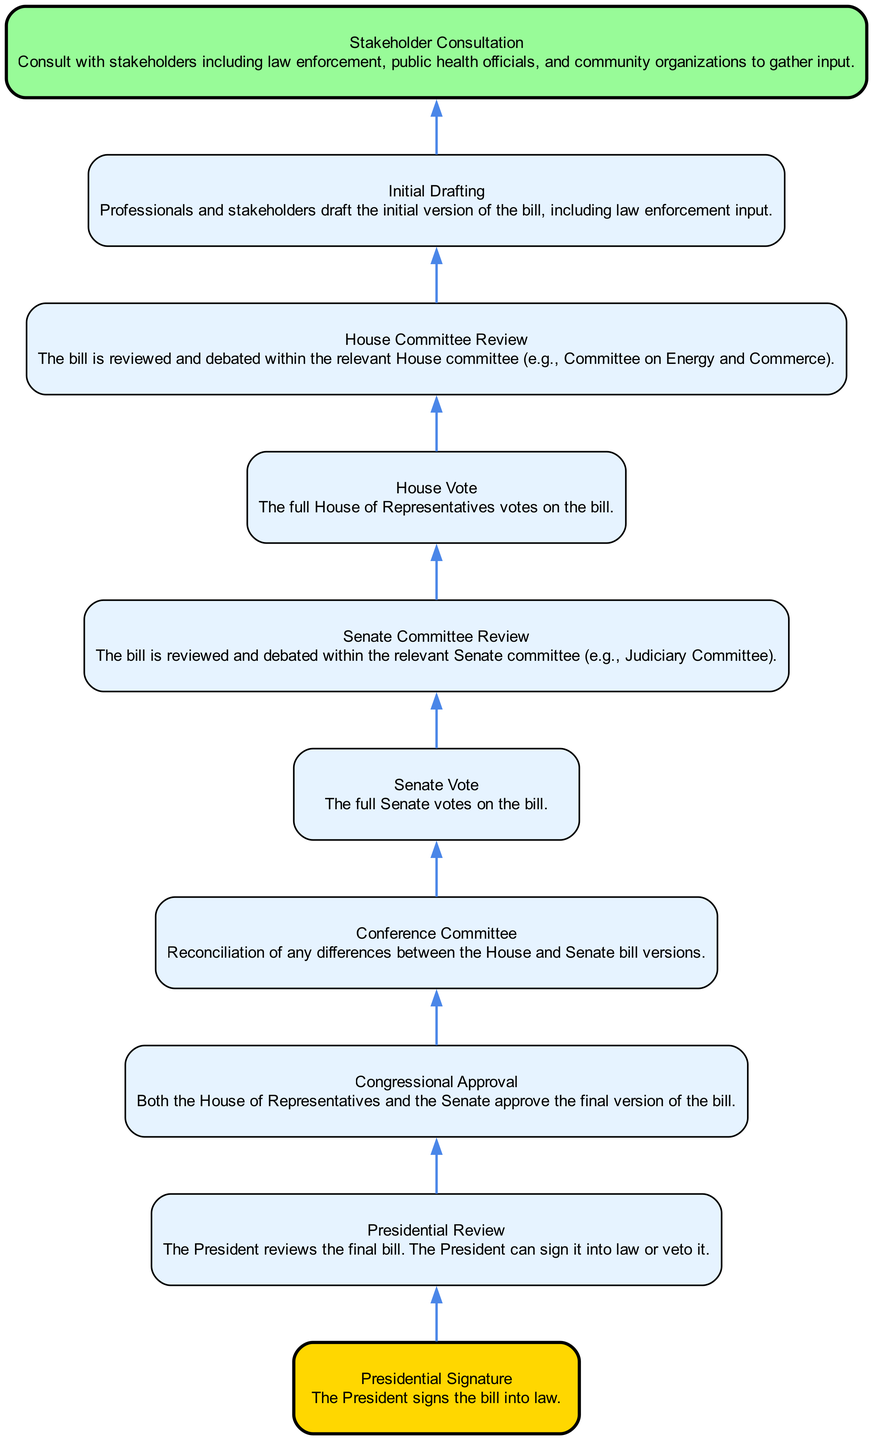What is the first step in the legislative process for enacting the substance abuse bill? The first step listed in the diagram is "Initial Drafting," where professionals and stakeholders draft the initial version of the bill, including law enforcement input.
Answer: Initial Drafting How many nodes are in the diagram? The diagram has a total of ten nodes representing each step in the legislative process.
Answer: 10 What follows after "Stakeholder Consultation"? After "Stakeholder Consultation," the next step is "Initial Drafting," indicating that the bill's initial version is created after consulting stakeholders.
Answer: Initial Drafting What happens during the "Conference Committee" stage? The "Conference Committee" stage involves reconciliation of any differences between the House and Senate bill versions, ensuring both chambers agree on the bill's content before the vote.
Answer: Reconciliation of differences Which step comes directly before "Presidential Signature"? "Presidential Review" comes directly before "Presidential Signature," as the President must review the bill before signing it into law or vetoing it.
Answer: Presidential Review What is the final outcome after "Presidential Signature"? The final outcome after "Presidential Signature" is that the bill is signed into law by the President, completing the legislative process.
Answer: Signed into law During which stage is the bill reviewed in the Senate? The bill is reviewed during the "Senate Committee Review" stage, where it is debated within the relevant Senate committee before it goes for a vote.
Answer: Senate Committee Review What must happen before "Congressional Approval"? Before "Congressional Approval," the full Senate must vote on the bill after it has been reviewed in the Senate committee, and the House must also vote on its version of the bill.
Answer: Senate Vote and House Vote 